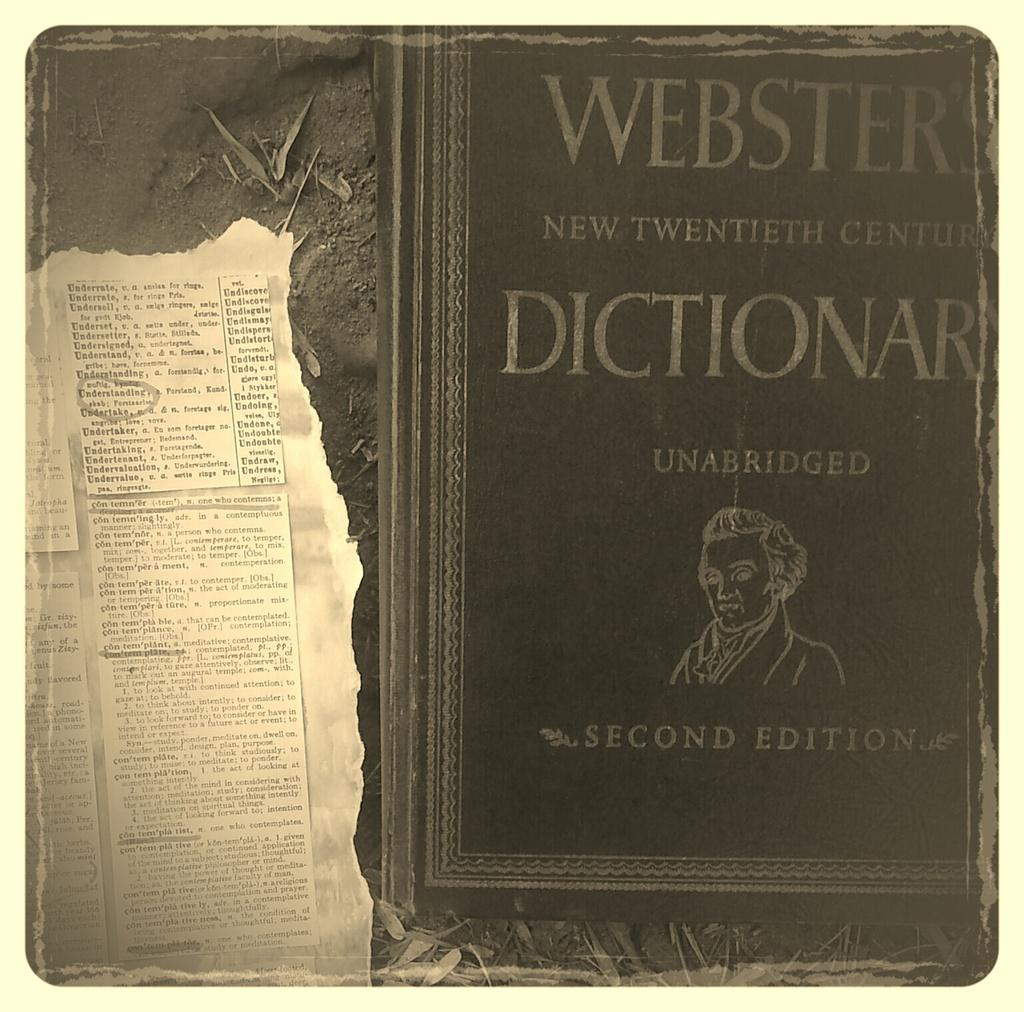<image>
Write a terse but informative summary of the picture. the cover of an old webster new twentieth century dictionary 